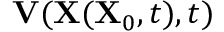Convert formula to latex. <formula><loc_0><loc_0><loc_500><loc_500>V ( X ( X _ { 0 } , t ) , t )</formula> 